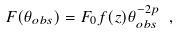Convert formula to latex. <formula><loc_0><loc_0><loc_500><loc_500>F ( \theta _ { o b s } ) = F _ { 0 } f ( z ) \theta _ { o b s } ^ { - 2 p } \ ,</formula> 